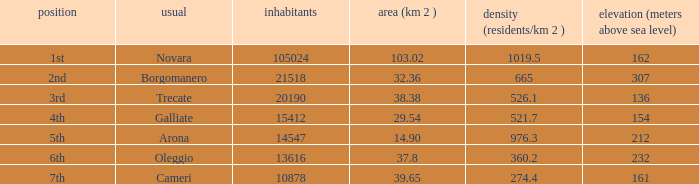Which common has an area (km2) of 38.38? Trecate. 